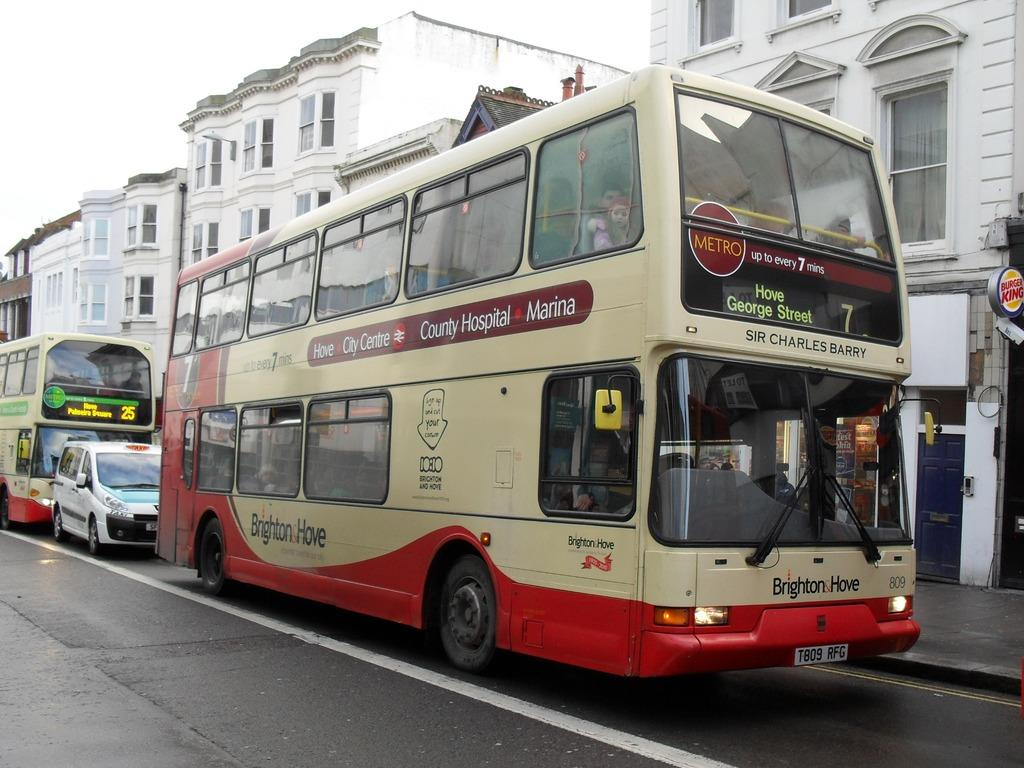<image>
Summarize the visual content of the image. a bus with the number 7 on it and the words hove george street on the front of it 